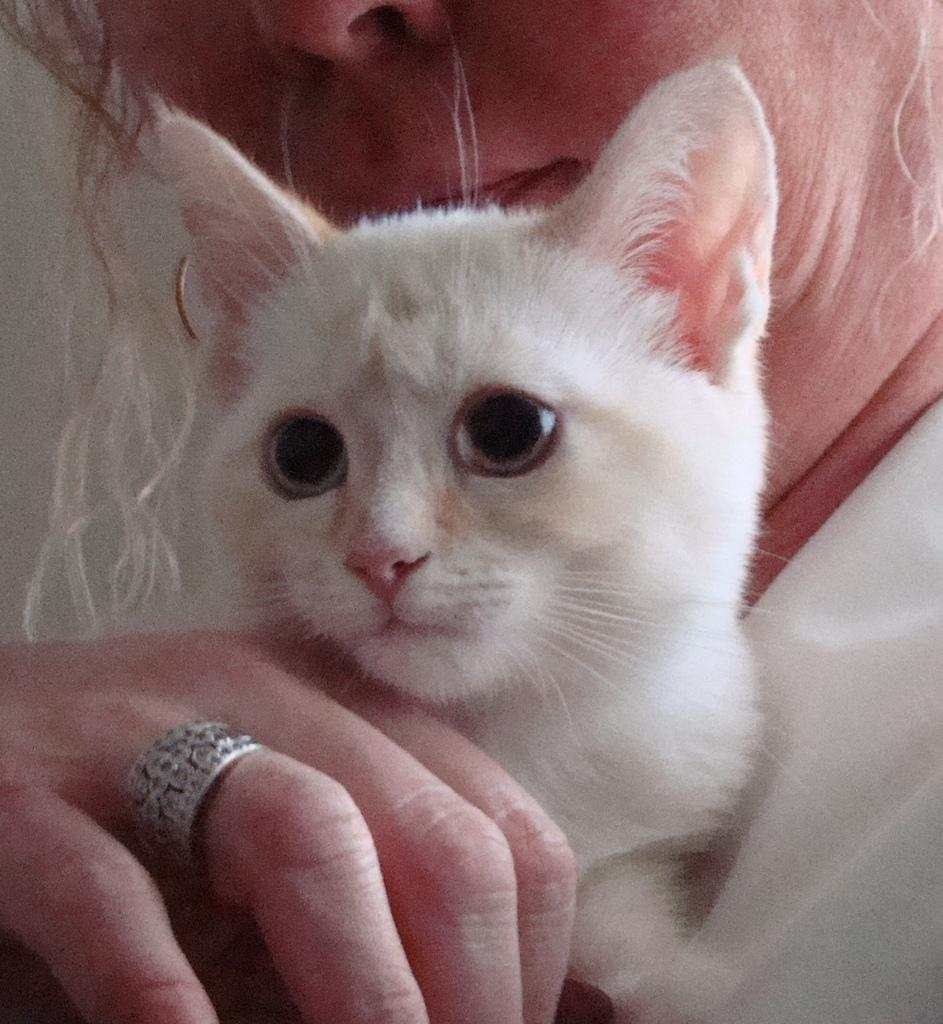Who is present in the image? There is a woman in the image. What is the woman holding? The woman is holding a cat. Can you describe any accessories the woman is wearing? The woman is wearing a finger ring. What can be seen on the left side of the image? There is a wall on the left side of the image. What type of wax is being used to create a gate in the image? There is no wax or gate present in the image. 